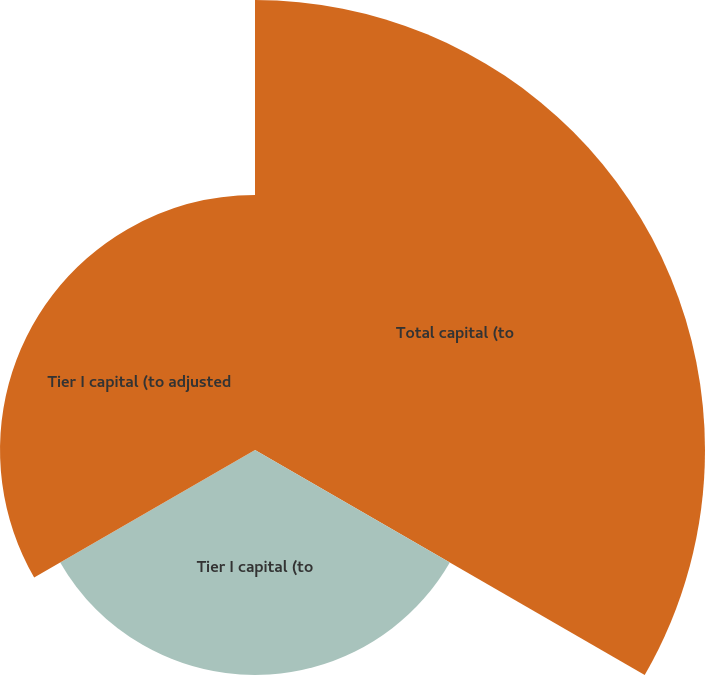Convert chart to OTSL. <chart><loc_0><loc_0><loc_500><loc_500><pie_chart><fcel>Total capital (to<fcel>Tier I capital (to<fcel>Tier I capital (to adjusted<nl><fcel>48.39%<fcel>24.19%<fcel>27.42%<nl></chart> 